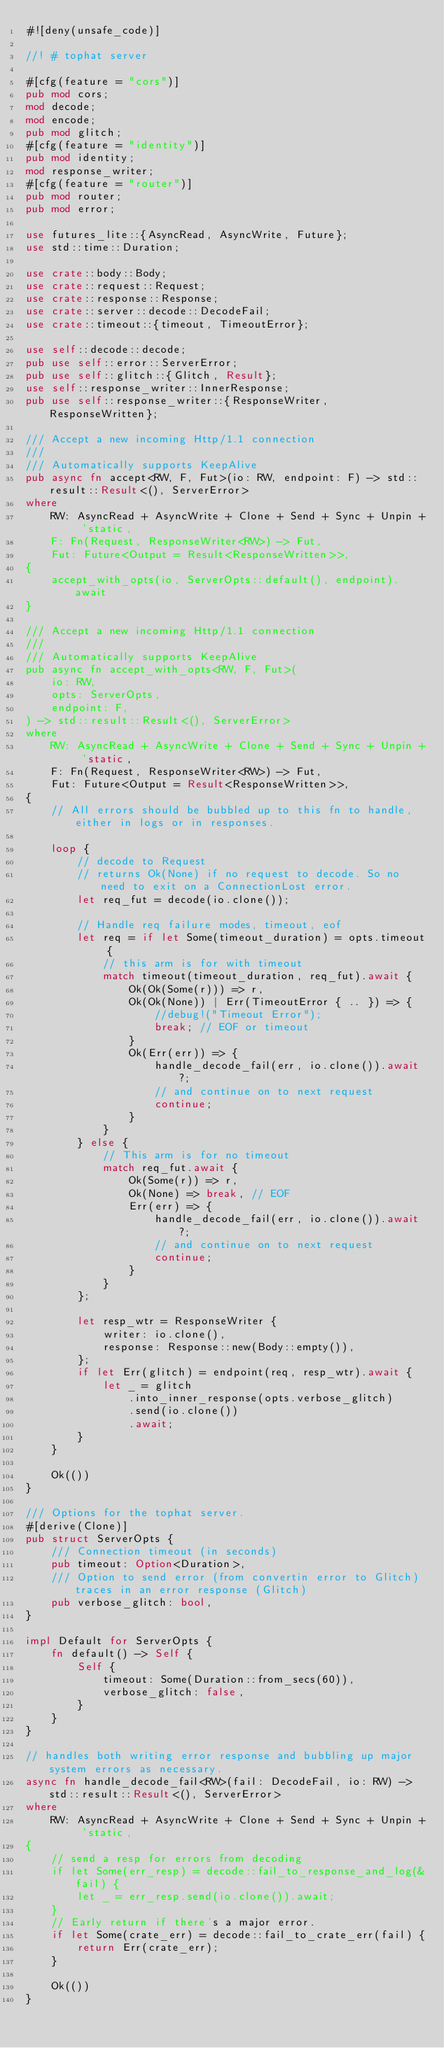<code> <loc_0><loc_0><loc_500><loc_500><_Rust_>#![deny(unsafe_code)]

//! # tophat server

#[cfg(feature = "cors")]
pub mod cors;
mod decode;
mod encode;
pub mod glitch;
#[cfg(feature = "identity")]
pub mod identity;
mod response_writer;
#[cfg(feature = "router")]
pub mod router;
pub mod error;

use futures_lite::{AsyncRead, AsyncWrite, Future};
use std::time::Duration;

use crate::body::Body;
use crate::request::Request;
use crate::response::Response;
use crate::server::decode::DecodeFail;
use crate::timeout::{timeout, TimeoutError};

use self::decode::decode;
pub use self::error::ServerError;
pub use self::glitch::{Glitch, Result};
use self::response_writer::InnerResponse;
pub use self::response_writer::{ResponseWriter, ResponseWritten};

/// Accept a new incoming Http/1.1 connection
///
/// Automatically supports KeepAlive
pub async fn accept<RW, F, Fut>(io: RW, endpoint: F) -> std::result::Result<(), ServerError>
where
    RW: AsyncRead + AsyncWrite + Clone + Send + Sync + Unpin + 'static,
    F: Fn(Request, ResponseWriter<RW>) -> Fut,
    Fut: Future<Output = Result<ResponseWritten>>,
{
    accept_with_opts(io, ServerOpts::default(), endpoint).await
}

/// Accept a new incoming Http/1.1 connection
///
/// Automatically supports KeepAlive
pub async fn accept_with_opts<RW, F, Fut>(
    io: RW,
    opts: ServerOpts,
    endpoint: F,
) -> std::result::Result<(), ServerError>
where
    RW: AsyncRead + AsyncWrite + Clone + Send + Sync + Unpin + 'static,
    F: Fn(Request, ResponseWriter<RW>) -> Fut,
    Fut: Future<Output = Result<ResponseWritten>>,
{
    // All errors should be bubbled up to this fn to handle, either in logs or in responses.

    loop {
        // decode to Request
        // returns Ok(None) if no request to decode. So no need to exit on a ConnectionLost error.
        let req_fut = decode(io.clone());

        // Handle req failure modes, timeout, eof
        let req = if let Some(timeout_duration) = opts.timeout {
            // this arm is for with timeout
            match timeout(timeout_duration, req_fut).await {
                Ok(Ok(Some(r))) => r,
                Ok(Ok(None)) | Err(TimeoutError { .. }) => {
                    //debug!("Timeout Error");
                    break; // EOF or timeout
                }
                Ok(Err(err)) => {
                    handle_decode_fail(err, io.clone()).await?;
                    // and continue on to next request
                    continue;
                }
            }
        } else {
            // This arm is for no timeout
            match req_fut.await {
                Ok(Some(r)) => r,
                Ok(None) => break, // EOF
                Err(err) => {
                    handle_decode_fail(err, io.clone()).await?;
                    // and continue on to next request
                    continue;
                }
            }
        };

        let resp_wtr = ResponseWriter {
            writer: io.clone(),
            response: Response::new(Body::empty()),
        };
        if let Err(glitch) = endpoint(req, resp_wtr).await {
            let _ = glitch
                .into_inner_response(opts.verbose_glitch)
                .send(io.clone())
                .await;
        }
    }

    Ok(())
}

/// Options for the tophat server.
#[derive(Clone)]
pub struct ServerOpts {
    /// Connection timeout (in seconds)
    pub timeout: Option<Duration>,
    /// Option to send error (from convertin error to Glitch) traces in an error response (Glitch)
    pub verbose_glitch: bool,
}

impl Default for ServerOpts {
    fn default() -> Self {
        Self {
            timeout: Some(Duration::from_secs(60)),
            verbose_glitch: false,
        }
    }
}

// handles both writing error response and bubbling up major system errors as necessary.
async fn handle_decode_fail<RW>(fail: DecodeFail, io: RW) -> std::result::Result<(), ServerError>
where
    RW: AsyncRead + AsyncWrite + Clone + Send + Sync + Unpin + 'static,
{
    // send a resp for errors from decoding
    if let Some(err_resp) = decode::fail_to_response_and_log(&fail) {
        let _ = err_resp.send(io.clone()).await;
    }
    // Early return if there's a major error.
    if let Some(crate_err) = decode::fail_to_crate_err(fail) {
        return Err(crate_err);
    }

    Ok(())
}
</code> 